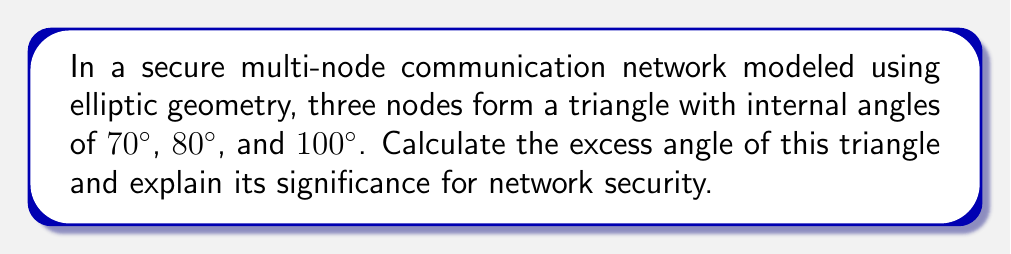Give your solution to this math problem. Let's approach this step-by-step:

1) In Euclidean geometry, the sum of angles in a triangle is always 180°. However, in elliptic geometry, the sum is always greater than 180°.

2) To find the excess angle, we first calculate the sum of the given angles:
   $$ 70° + 80° + 100° = 250° $$

3) The excess angle is the difference between this sum and 180°:
   $$ 250° - 180° = 70° $$

4) In elliptic geometry, the excess angle (E) is related to the area (A) of the triangle and the radius of curvature (R) of the space:
   $$ E = \frac{A}{R^2} $$

5) This relationship is significant for network security because:
   a) It indicates that the communication path between nodes is curved, not straight.
   b) The larger the excess angle, the more curved the space, which can affect signal propagation and encryption strategies.
   c) In a multi-node network, understanding this curvature helps in optimizing node placement and signal routing for secure communication.

6) A larger excess angle could imply:
   - More potential for signal interference
   - Need for stronger encryption due to increased path complexity
   - Opportunity for unique security protocols leveraging the space's curvature

7) For a CEO, this understanding can inform decisions on network infrastructure, security protocols, and resource allocation for maintaining a robust and secure communication system.
Answer: 70° 